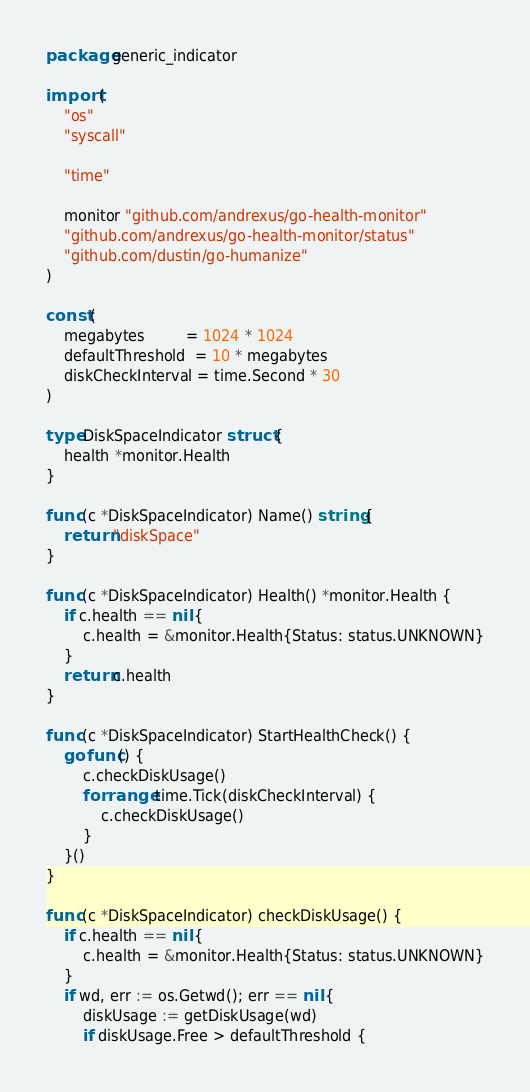Convert code to text. <code><loc_0><loc_0><loc_500><loc_500><_Go_>package generic_indicator

import (
	"os"
	"syscall"

	"time"

	monitor "github.com/andrexus/go-health-monitor"
	"github.com/andrexus/go-health-monitor/status"
	"github.com/dustin/go-humanize"
)

const (
	megabytes         = 1024 * 1024
	defaultThreshold  = 10 * megabytes
	diskCheckInterval = time.Second * 30
)

type DiskSpaceIndicator struct {
	health *monitor.Health
}

func (c *DiskSpaceIndicator) Name() string {
	return "diskSpace"
}

func (c *DiskSpaceIndicator) Health() *monitor.Health {
	if c.health == nil {
		c.health = &monitor.Health{Status: status.UNKNOWN}
	}
	return c.health
}

func (c *DiskSpaceIndicator) StartHealthCheck() {
	go func() {
		c.checkDiskUsage()
		for range time.Tick(diskCheckInterval) {
			c.checkDiskUsage()
		}
	}()
}

func (c *DiskSpaceIndicator) checkDiskUsage() {
	if c.health == nil {
		c.health = &monitor.Health{Status: status.UNKNOWN}
	}
	if wd, err := os.Getwd(); err == nil {
		diskUsage := getDiskUsage(wd)
		if diskUsage.Free > defaultThreshold {</code> 